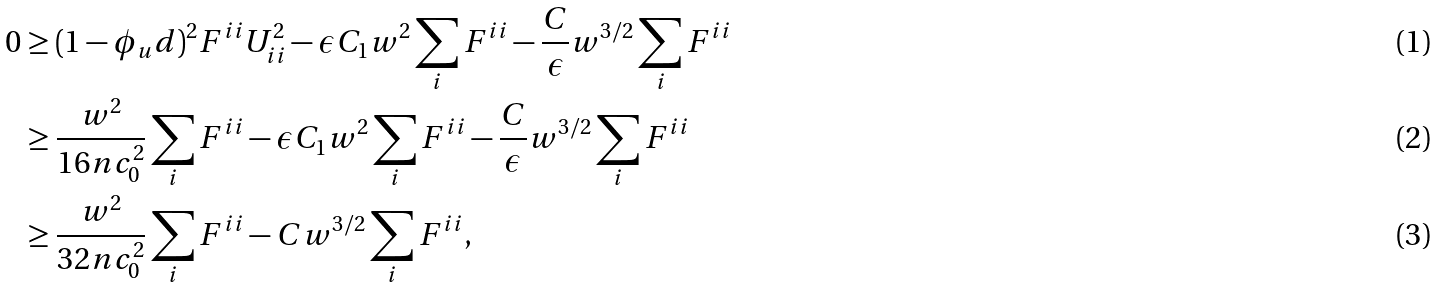<formula> <loc_0><loc_0><loc_500><loc_500>0 & \geq ( 1 - \phi _ { u } d ) ^ { 2 } F ^ { i i } U _ { i i } ^ { 2 } - \epsilon C _ { 1 } w ^ { 2 } \sum _ { i } F ^ { i i } - \frac { C } { \epsilon } w ^ { 3 / 2 } \sum _ { i } F ^ { i i } \\ & \geq \frac { w ^ { 2 } } { 1 6 n c _ { 0 } ^ { 2 } } \sum _ { i } F ^ { i i } - \epsilon C _ { 1 } w ^ { 2 } \sum _ { i } F ^ { i i } - \frac { C } { \epsilon } w ^ { 3 / 2 } \sum _ { i } F ^ { i i } \\ & \geq \frac { w ^ { 2 } } { 3 2 n c _ { 0 } ^ { 2 } } \sum _ { i } F ^ { i i } - C w ^ { 3 / 2 } \sum _ { i } F ^ { i i } ,</formula> 